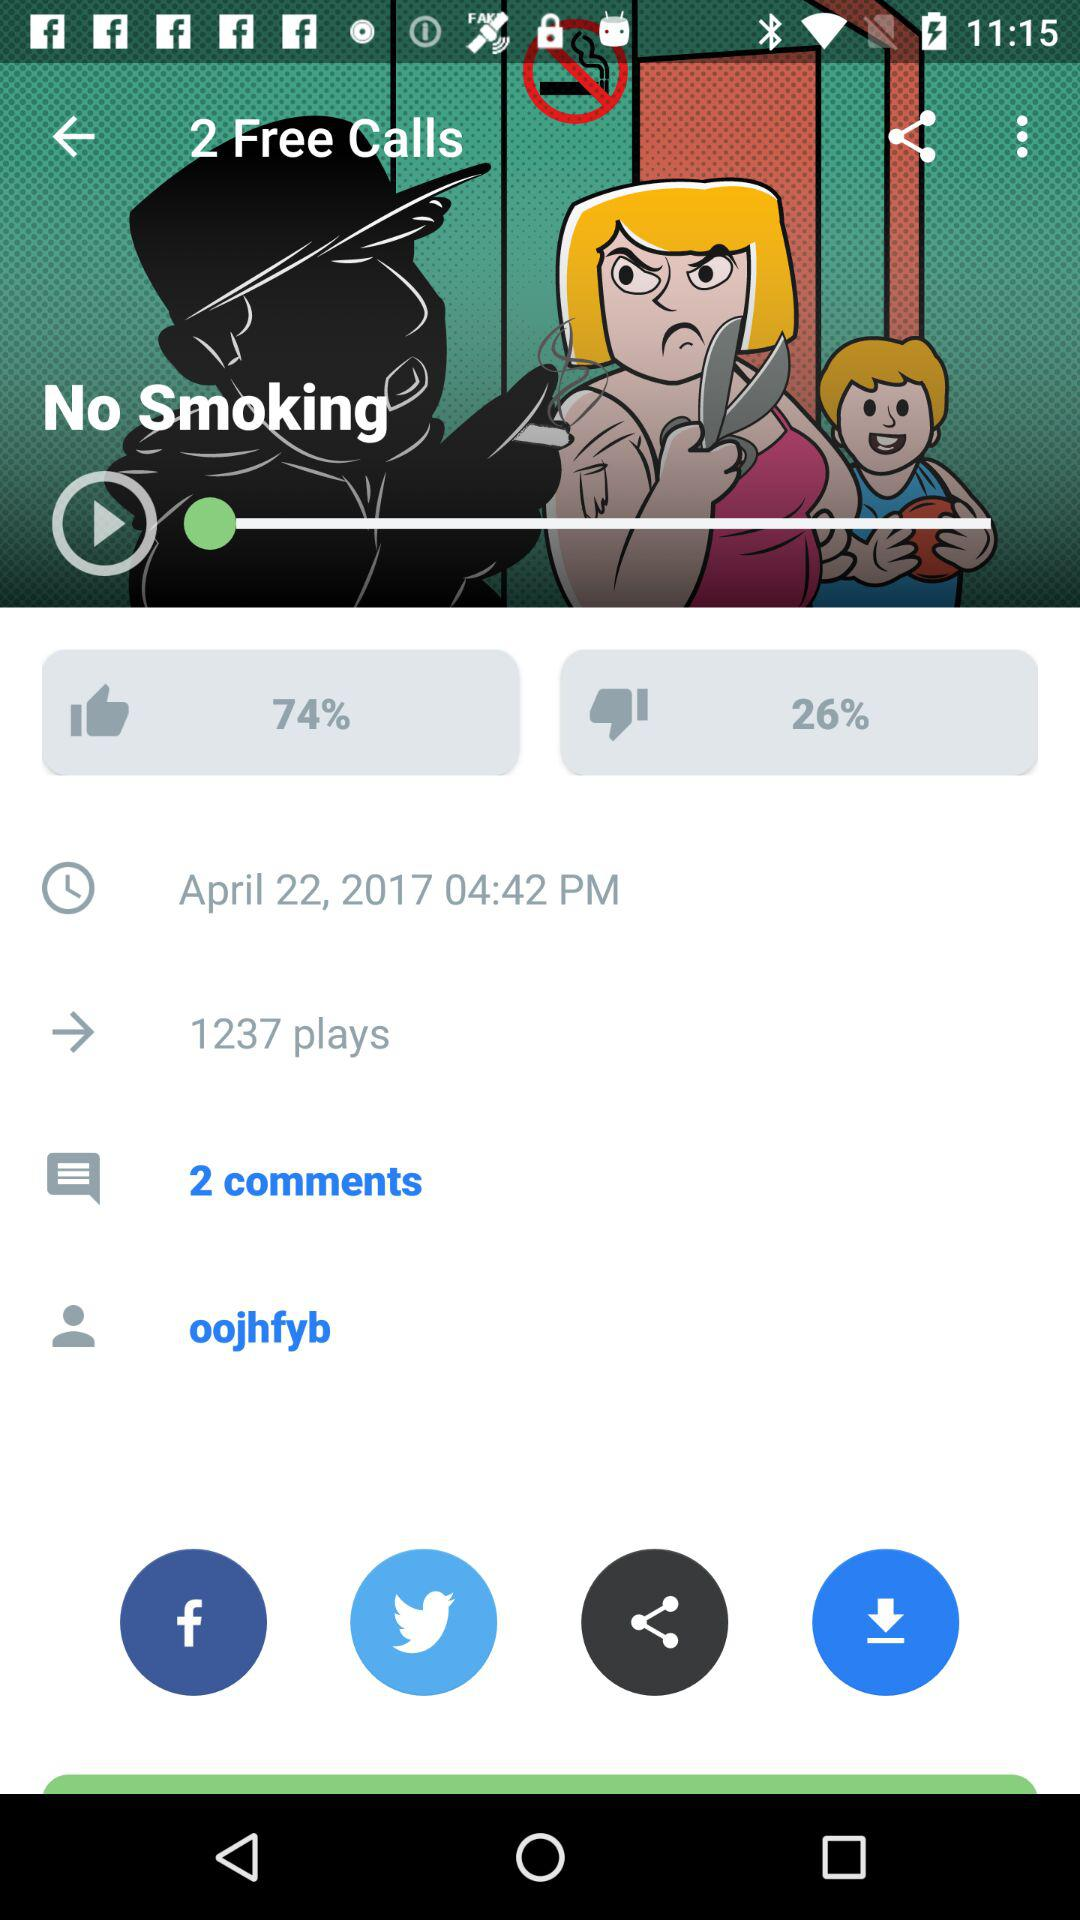What is the number of plays? The number of plays is 1237. 